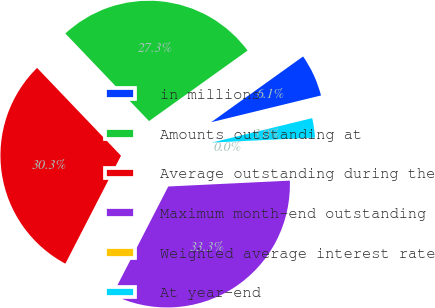Convert chart. <chart><loc_0><loc_0><loc_500><loc_500><pie_chart><fcel>in millions<fcel>Amounts outstanding at<fcel>Average outstanding during the<fcel>Maximum month-end outstanding<fcel>Weighted average interest rate<fcel>At year-end<nl><fcel>6.08%<fcel>27.25%<fcel>30.29%<fcel>33.33%<fcel>0.0%<fcel>3.04%<nl></chart> 